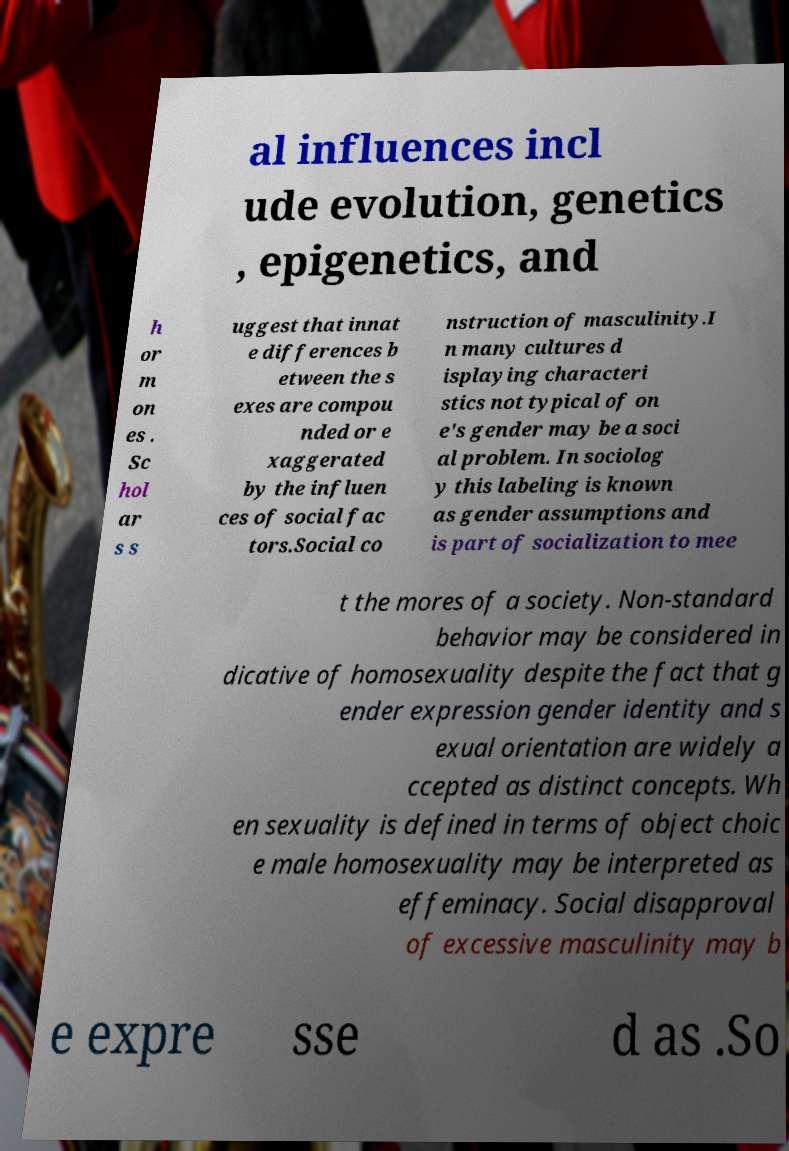Could you extract and type out the text from this image? al influences incl ude evolution, genetics , epigenetics, and h or m on es . Sc hol ar s s uggest that innat e differences b etween the s exes are compou nded or e xaggerated by the influen ces of social fac tors.Social co nstruction of masculinity.I n many cultures d isplaying characteri stics not typical of on e's gender may be a soci al problem. In sociolog y this labeling is known as gender assumptions and is part of socialization to mee t the mores of a society. Non-standard behavior may be considered in dicative of homosexuality despite the fact that g ender expression gender identity and s exual orientation are widely a ccepted as distinct concepts. Wh en sexuality is defined in terms of object choic e male homosexuality may be interpreted as effeminacy. Social disapproval of excessive masculinity may b e expre sse d as .So 